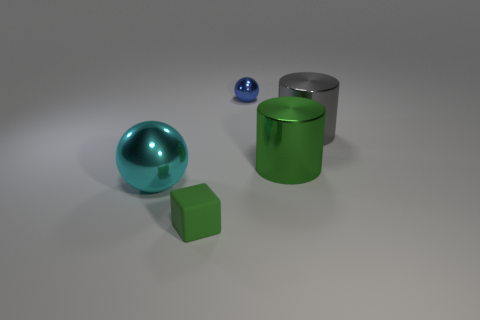Is there a blue ball made of the same material as the small block?
Give a very brief answer. No. There is a object that is left of the small blue ball and behind the tiny matte thing; what is its color?
Keep it short and to the point. Cyan. What number of other objects are the same color as the tiny cube?
Offer a terse response. 1. There is a sphere that is in front of the large thing that is to the right of the big cylinder in front of the large gray metal cylinder; what is it made of?
Offer a very short reply. Metal. How many cylinders are either small matte things or gray things?
Offer a terse response. 1. What number of matte blocks are behind the shiny object that is in front of the large metal cylinder that is on the left side of the big gray shiny thing?
Your response must be concise. 0. Is the tiny metal object the same shape as the large cyan object?
Keep it short and to the point. Yes. Is the material of the large cylinder that is in front of the large gray shiny thing the same as the ball that is left of the small blue object?
Your answer should be compact. Yes. What number of things are either large metal things that are to the left of the big green object or large metallic things on the right side of the big cyan metallic ball?
Provide a succinct answer. 3. Is there anything else that has the same shape as the small green thing?
Ensure brevity in your answer.  No. 